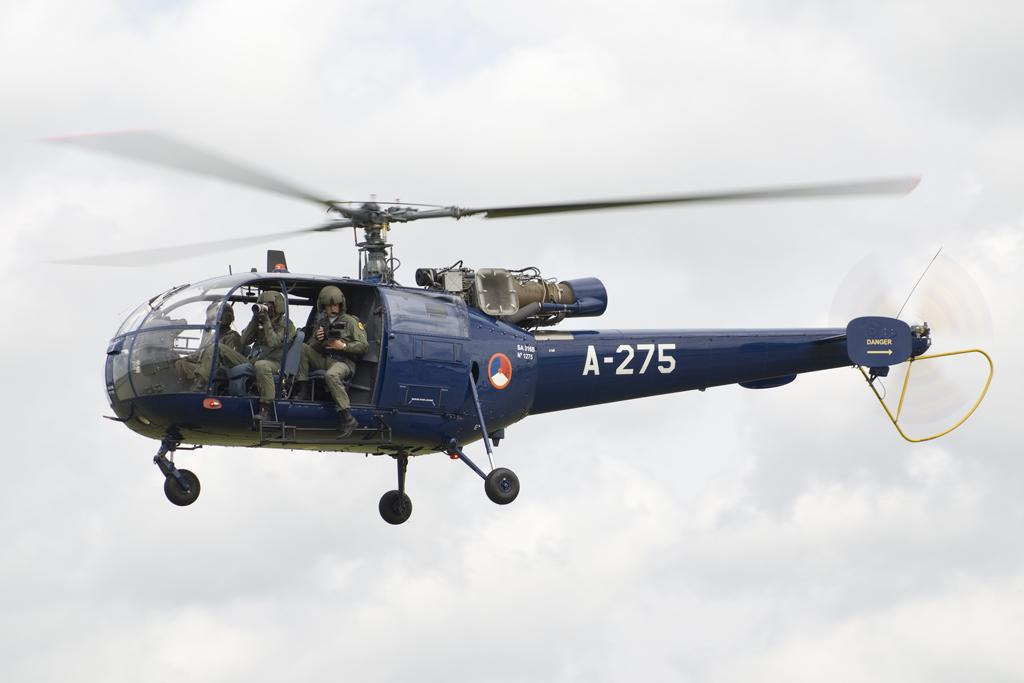What is the main subject of the image? The main subject of the image is a helicopter. What can be seen inside the helicopter? There are people sitting in the helicopter. What are the people wearing? The people are wearing clothes, helmets, and shoes. How would you describe the sky in the image? The sky is cloudy in the image. What type of vein is visible on the people's faces in the image? There are no visible veins on the people's faces in the image. Can you tell me how many times the people in the helicopter have laughed during their flight? There is no indication of laughter or any emotions in the image, so it cannot be determined. 